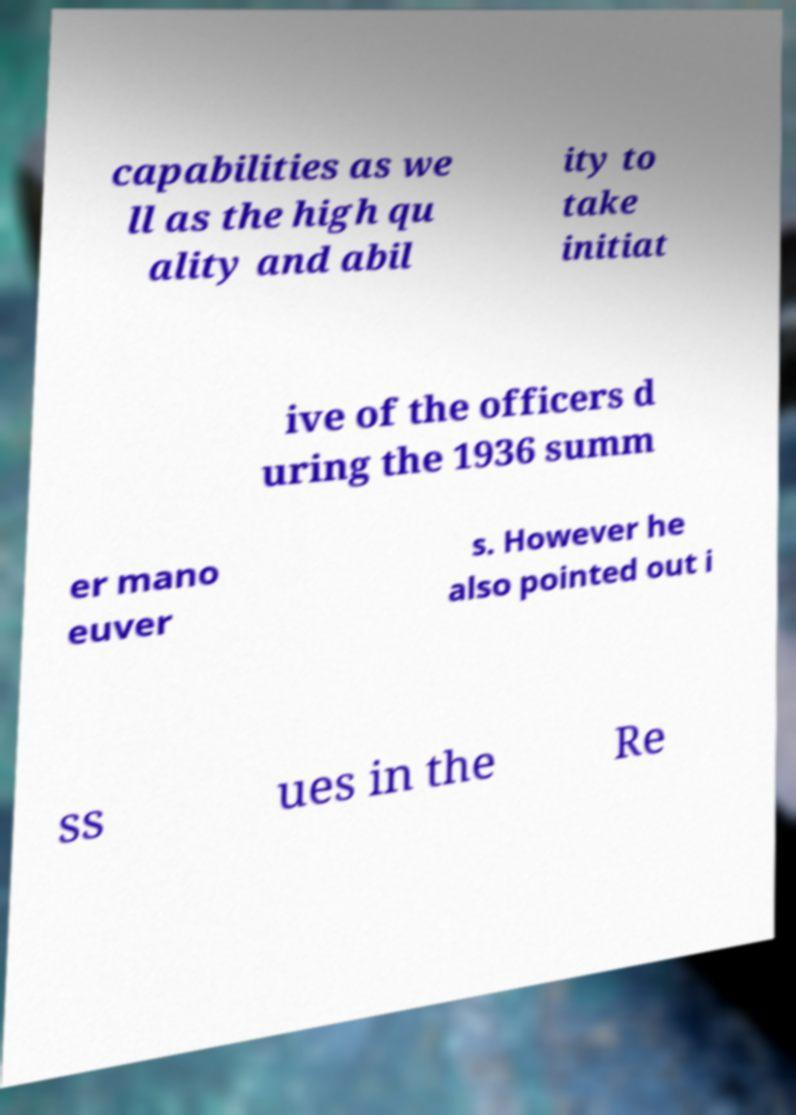Please read and relay the text visible in this image. What does it say? capabilities as we ll as the high qu ality and abil ity to take initiat ive of the officers d uring the 1936 summ er mano euver s. However he also pointed out i ss ues in the Re 